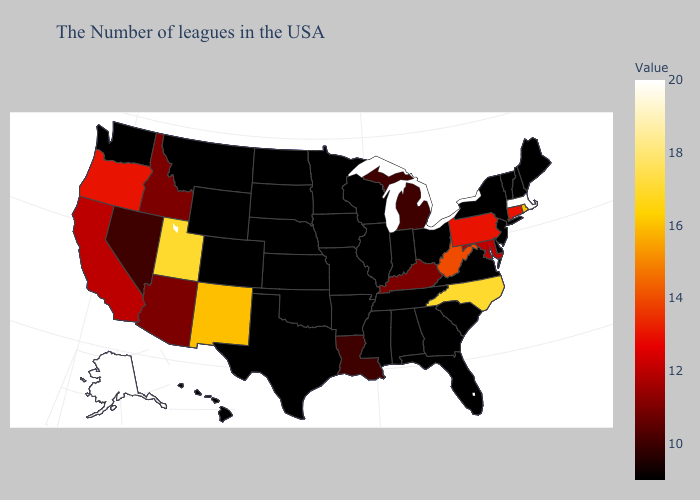Does Illinois have a lower value than Idaho?
Be succinct. Yes. Among the states that border Delaware , which have the lowest value?
Quick response, please. New Jersey. Does Missouri have a lower value than Pennsylvania?
Give a very brief answer. Yes. Among the states that border Maryland , does West Virginia have the lowest value?
Keep it brief. No. Among the states that border Oklahoma , which have the highest value?
Concise answer only. New Mexico. 